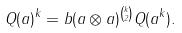<formula> <loc_0><loc_0><loc_500><loc_500>Q ( a ) ^ { k } = b ( a \otimes a ) ^ { \binom { k } { 2 } } Q ( a ^ { k } ) .</formula> 